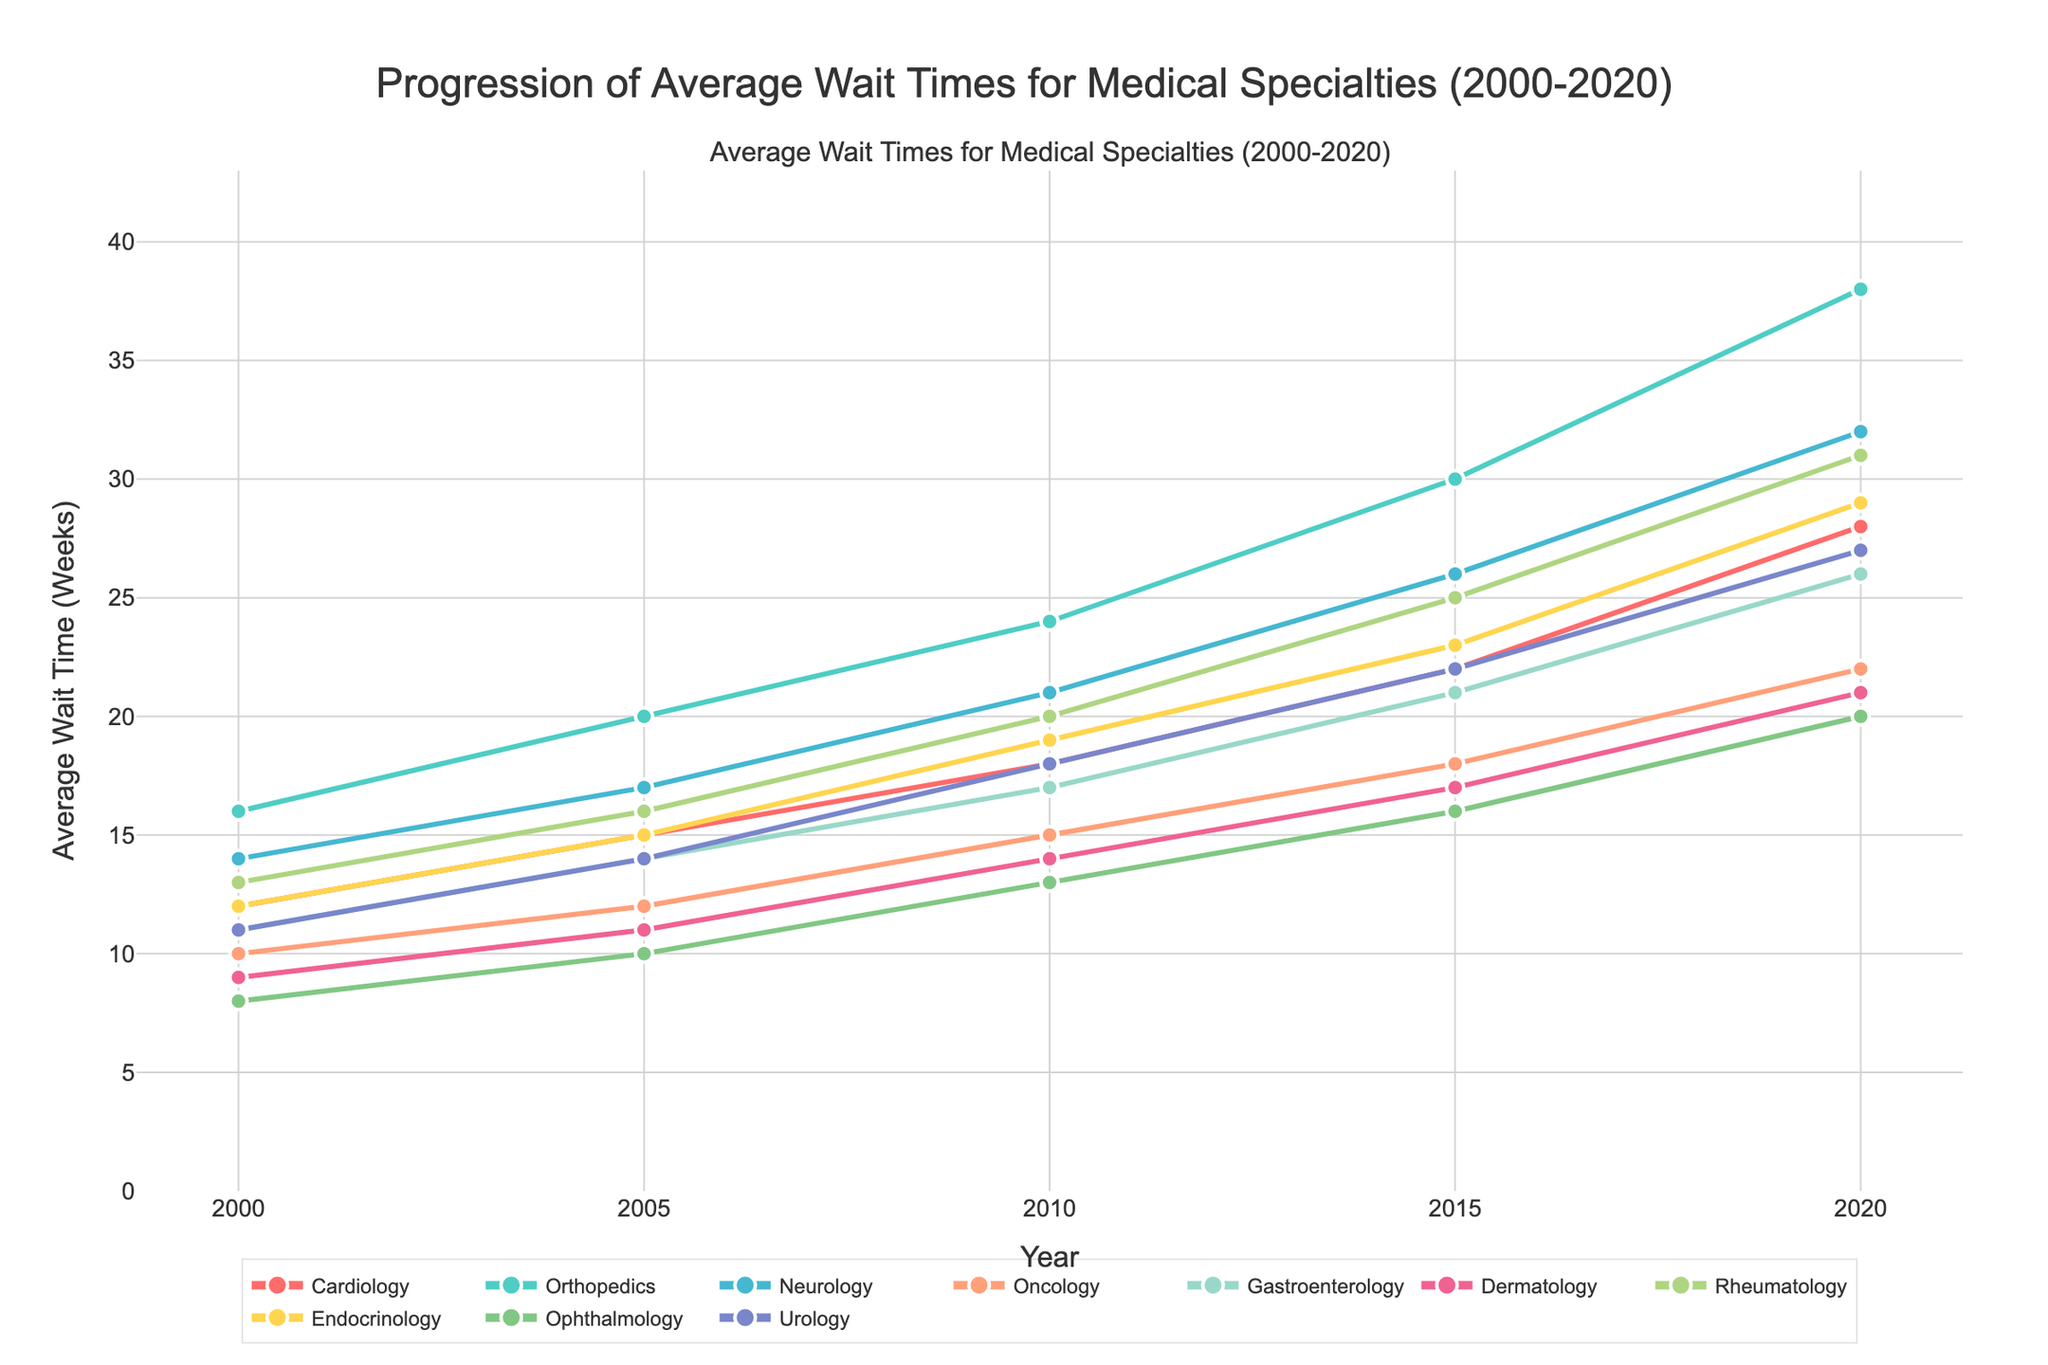Which specialty had the highest average wait time in 2020? First, we look at the year 2020 on the x-axis. Then, we examine the y-values for all specialties in that year. Orthopedics has the highest average wait time of 38 weeks.
Answer: Orthopedics Between 2000 and 2020, which specialty showed the greatest increase in average wait times? Calculate the increase for each specialty by subtracting the 2000 value from the 2020 value. Orthopedics increased the most, from 16 weeks in 2000 to 38 weeks in 2020, an increase of 22 weeks.
Answer: Orthopedics What is the difference in average wait times between Neurology and Gastroenterology in 2010? Look at the average wait times for Neurology and Gastroenterology in 2010. Neurology is at 21 weeks, and Gastroenterology is at 17 weeks. The difference is 21 - 17 = 4 weeks.
Answer: 4 weeks Which specialty had the smallest change in average wait time from 2015 to 2020? Calculate the change for each specialty by subtracting the 2015 value from the 2020 value. Dermatology changed the least, from 17 weeks to 21 weeks, an increase of 4 weeks.
Answer: Dermatology What was the average wait time for Cardiology over the period from 2000 to 2020? Add the wait times for Cardiology for the years 2000 (12), 2005 (15), 2010 (18), 2015 (22), and 2020 (28). The sum is 12 + 15 + 18 + 22 + 28 = 95. Divide by the number of years (5): 95 / 5 = 19 weeks.
Answer: 19 weeks Which two specialties had the closest average wait times in 2005? Compare the wait times for all specialties in 2005. Cardiology and Urology both had wait times of 15 and 14 weeks, respectively, with a difference of just 1 week.
Answer: Cardiology and Urology In 2020, which specialty's wait time exceeded 25 weeks but was less than 30 weeks? Look at the wait times for 2020 between 25 and 30 weeks. Neurology and Endocrinology both fit this range, with Neurology at 32 weeks being slightly above 30.
Answer: Endocrinology What was the total wait time for Dermatology over the two decades (2000, 2005, 2010, 2015, 2020)? Sum the Dermatology wait times for all the years: 9 (2000) + 11 (2005) + 14 (2010) + 17 (2015) + 21 (2020). The total is 9 + 11 + 14 + 17 + 21 = 72 weeks.
Answer: 72 weeks 